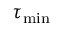Convert formula to latex. <formula><loc_0><loc_0><loc_500><loc_500>\tau _ { \min }</formula> 